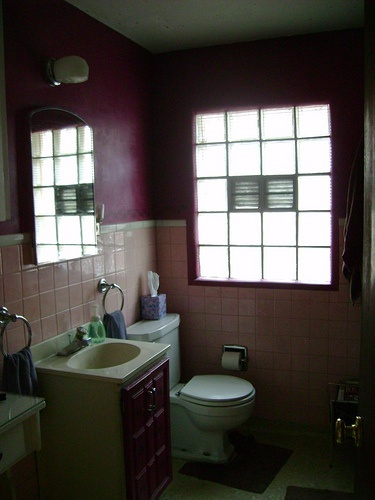Describe the objects in this image and their specific colors. I can see toilet in black, gray, and darkgray tones, sink in black, gray, and darkgreen tones, and bottle in black, teal, and darkgreen tones in this image. 